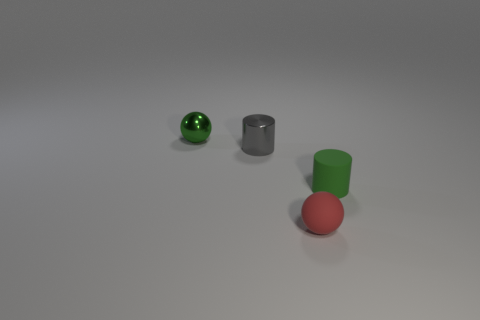Add 3 green objects. How many objects exist? 7 Subtract all gray cylinders. How many cylinders are left? 1 Subtract 0 red cubes. How many objects are left? 4 Subtract 1 cylinders. How many cylinders are left? 1 Subtract all gray spheres. Subtract all purple cylinders. How many spheres are left? 2 Subtract all gray cubes. How many yellow cylinders are left? 0 Subtract all red balls. Subtract all small purple rubber things. How many objects are left? 3 Add 4 tiny green matte cylinders. How many tiny green matte cylinders are left? 5 Add 3 tiny green spheres. How many tiny green spheres exist? 4 